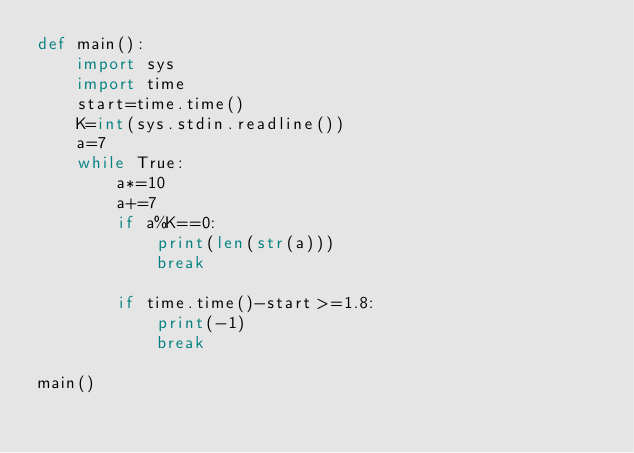Convert code to text. <code><loc_0><loc_0><loc_500><loc_500><_Python_>def main():
    import sys
    import time
    start=time.time()
    K=int(sys.stdin.readline())
    a=7
    while True:
        a*=10
        a+=7
        if a%K==0:
            print(len(str(a)))
            break
    
        if time.time()-start>=1.8:
            print(-1)
            break

main()</code> 